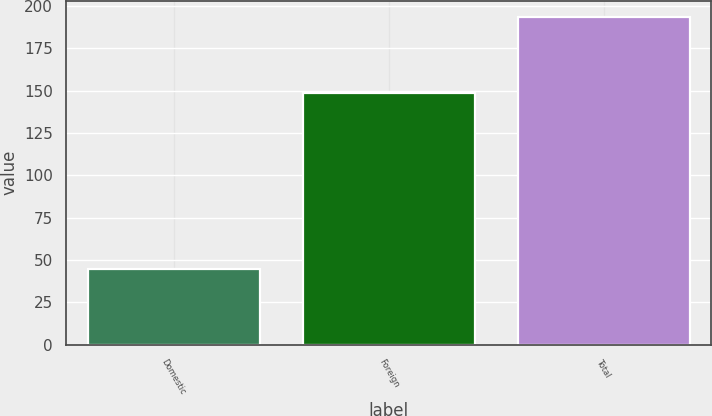Convert chart to OTSL. <chart><loc_0><loc_0><loc_500><loc_500><bar_chart><fcel>Domestic<fcel>Foreign<fcel>Total<nl><fcel>44.9<fcel>148.4<fcel>193.3<nl></chart> 